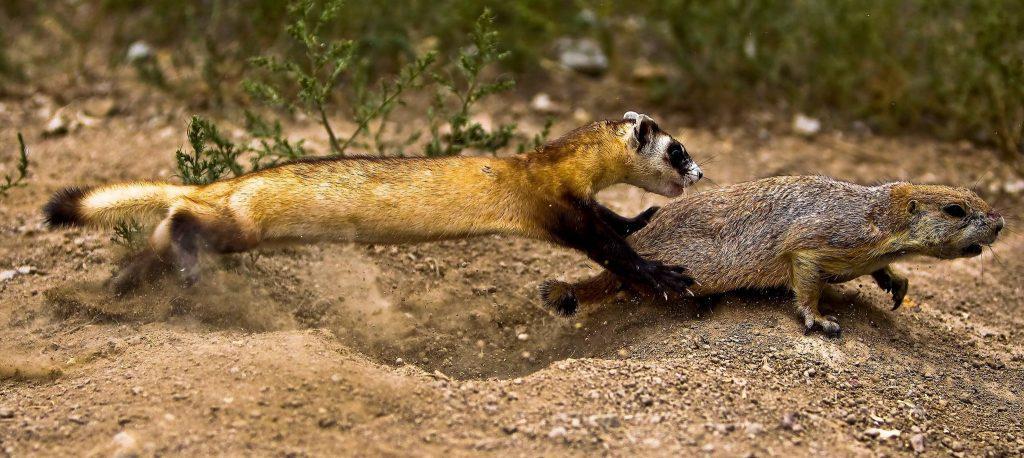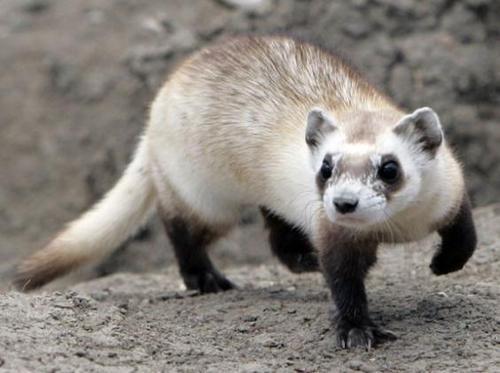The first image is the image on the left, the second image is the image on the right. Analyze the images presented: Is the assertion "ferrets mouth is open wide" valid? Answer yes or no. No. The first image is the image on the left, the second image is the image on the right. Analyze the images presented: Is the assertion "At least one of the images shows a ferret with it's mouth wide open." valid? Answer yes or no. No. 